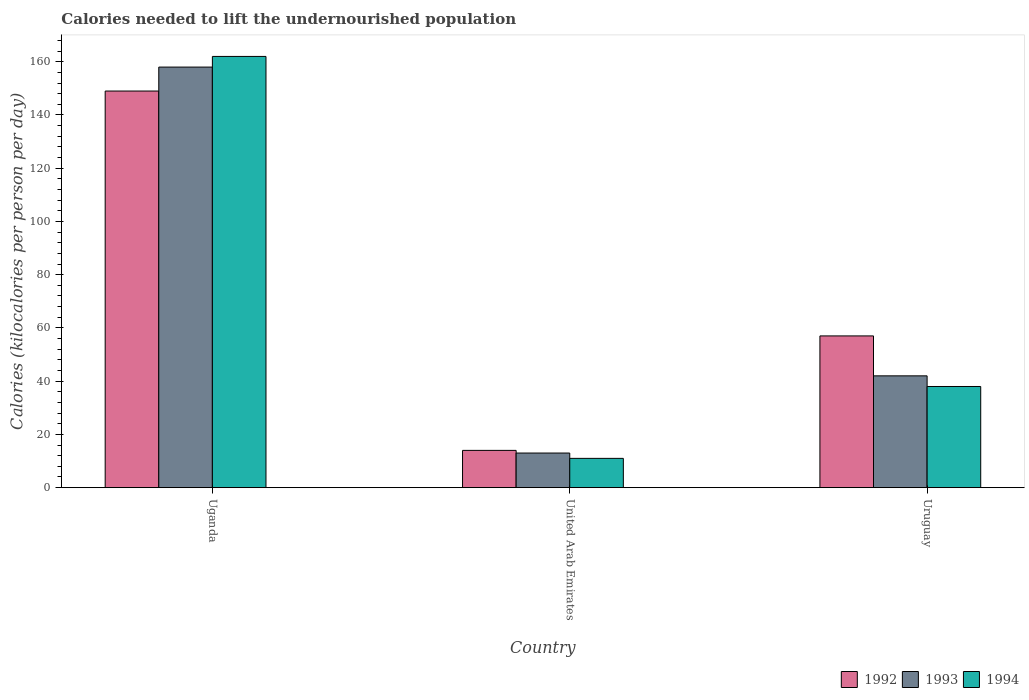How many different coloured bars are there?
Your response must be concise. 3. How many groups of bars are there?
Your answer should be compact. 3. Are the number of bars per tick equal to the number of legend labels?
Make the answer very short. Yes. Are the number of bars on each tick of the X-axis equal?
Make the answer very short. Yes. How many bars are there on the 3rd tick from the left?
Make the answer very short. 3. How many bars are there on the 3rd tick from the right?
Keep it short and to the point. 3. What is the label of the 2nd group of bars from the left?
Ensure brevity in your answer.  United Arab Emirates. What is the total calories needed to lift the undernourished population in 1994 in Uganda?
Your answer should be compact. 162. Across all countries, what is the maximum total calories needed to lift the undernourished population in 1994?
Your answer should be compact. 162. Across all countries, what is the minimum total calories needed to lift the undernourished population in 1994?
Your answer should be compact. 11. In which country was the total calories needed to lift the undernourished population in 1992 maximum?
Offer a very short reply. Uganda. In which country was the total calories needed to lift the undernourished population in 1994 minimum?
Offer a terse response. United Arab Emirates. What is the total total calories needed to lift the undernourished population in 1993 in the graph?
Give a very brief answer. 213. What is the difference between the total calories needed to lift the undernourished population in 1992 in Uganda and that in United Arab Emirates?
Ensure brevity in your answer.  135. What is the difference between the total calories needed to lift the undernourished population in 1993 in United Arab Emirates and the total calories needed to lift the undernourished population in 1994 in Uganda?
Offer a terse response. -149. What is the average total calories needed to lift the undernourished population in 1993 per country?
Your response must be concise. 71. What is the ratio of the total calories needed to lift the undernourished population in 1994 in Uganda to that in Uruguay?
Make the answer very short. 4.26. Is the total calories needed to lift the undernourished population in 1994 in Uganda less than that in United Arab Emirates?
Give a very brief answer. No. What is the difference between the highest and the second highest total calories needed to lift the undernourished population in 1992?
Your response must be concise. -92. What is the difference between the highest and the lowest total calories needed to lift the undernourished population in 1993?
Give a very brief answer. 145. In how many countries, is the total calories needed to lift the undernourished population in 1992 greater than the average total calories needed to lift the undernourished population in 1992 taken over all countries?
Give a very brief answer. 1. Is the sum of the total calories needed to lift the undernourished population in 1993 in Uganda and Uruguay greater than the maximum total calories needed to lift the undernourished population in 1992 across all countries?
Your response must be concise. Yes. What does the 1st bar from the right in United Arab Emirates represents?
Make the answer very short. 1994. How many bars are there?
Your answer should be compact. 9. How many countries are there in the graph?
Your answer should be very brief. 3. Are the values on the major ticks of Y-axis written in scientific E-notation?
Give a very brief answer. No. Does the graph contain any zero values?
Your answer should be compact. No. Does the graph contain grids?
Your response must be concise. No. Where does the legend appear in the graph?
Keep it short and to the point. Bottom right. How are the legend labels stacked?
Ensure brevity in your answer.  Horizontal. What is the title of the graph?
Your answer should be very brief. Calories needed to lift the undernourished population. What is the label or title of the Y-axis?
Offer a terse response. Calories (kilocalories per person per day). What is the Calories (kilocalories per person per day) of 1992 in Uganda?
Offer a terse response. 149. What is the Calories (kilocalories per person per day) of 1993 in Uganda?
Offer a very short reply. 158. What is the Calories (kilocalories per person per day) of 1994 in Uganda?
Your answer should be very brief. 162. What is the Calories (kilocalories per person per day) in 1992 in United Arab Emirates?
Your response must be concise. 14. What is the Calories (kilocalories per person per day) of 1994 in United Arab Emirates?
Your response must be concise. 11. What is the Calories (kilocalories per person per day) in 1992 in Uruguay?
Give a very brief answer. 57. Across all countries, what is the maximum Calories (kilocalories per person per day) in 1992?
Your answer should be very brief. 149. Across all countries, what is the maximum Calories (kilocalories per person per day) of 1993?
Your answer should be very brief. 158. Across all countries, what is the maximum Calories (kilocalories per person per day) in 1994?
Offer a terse response. 162. Across all countries, what is the minimum Calories (kilocalories per person per day) in 1992?
Provide a short and direct response. 14. What is the total Calories (kilocalories per person per day) of 1992 in the graph?
Make the answer very short. 220. What is the total Calories (kilocalories per person per day) of 1993 in the graph?
Keep it short and to the point. 213. What is the total Calories (kilocalories per person per day) of 1994 in the graph?
Your answer should be very brief. 211. What is the difference between the Calories (kilocalories per person per day) of 1992 in Uganda and that in United Arab Emirates?
Ensure brevity in your answer.  135. What is the difference between the Calories (kilocalories per person per day) of 1993 in Uganda and that in United Arab Emirates?
Offer a very short reply. 145. What is the difference between the Calories (kilocalories per person per day) in 1994 in Uganda and that in United Arab Emirates?
Keep it short and to the point. 151. What is the difference between the Calories (kilocalories per person per day) in 1992 in Uganda and that in Uruguay?
Your response must be concise. 92. What is the difference between the Calories (kilocalories per person per day) of 1993 in Uganda and that in Uruguay?
Ensure brevity in your answer.  116. What is the difference between the Calories (kilocalories per person per day) in 1994 in Uganda and that in Uruguay?
Give a very brief answer. 124. What is the difference between the Calories (kilocalories per person per day) of 1992 in United Arab Emirates and that in Uruguay?
Provide a short and direct response. -43. What is the difference between the Calories (kilocalories per person per day) of 1992 in Uganda and the Calories (kilocalories per person per day) of 1993 in United Arab Emirates?
Your answer should be very brief. 136. What is the difference between the Calories (kilocalories per person per day) of 1992 in Uganda and the Calories (kilocalories per person per day) of 1994 in United Arab Emirates?
Keep it short and to the point. 138. What is the difference between the Calories (kilocalories per person per day) in 1993 in Uganda and the Calories (kilocalories per person per day) in 1994 in United Arab Emirates?
Keep it short and to the point. 147. What is the difference between the Calories (kilocalories per person per day) in 1992 in Uganda and the Calories (kilocalories per person per day) in 1993 in Uruguay?
Offer a terse response. 107. What is the difference between the Calories (kilocalories per person per day) in 1992 in Uganda and the Calories (kilocalories per person per day) in 1994 in Uruguay?
Ensure brevity in your answer.  111. What is the difference between the Calories (kilocalories per person per day) of 1993 in Uganda and the Calories (kilocalories per person per day) of 1994 in Uruguay?
Provide a succinct answer. 120. What is the difference between the Calories (kilocalories per person per day) of 1992 in United Arab Emirates and the Calories (kilocalories per person per day) of 1993 in Uruguay?
Offer a very short reply. -28. What is the difference between the Calories (kilocalories per person per day) in 1992 in United Arab Emirates and the Calories (kilocalories per person per day) in 1994 in Uruguay?
Your response must be concise. -24. What is the average Calories (kilocalories per person per day) of 1992 per country?
Your answer should be very brief. 73.33. What is the average Calories (kilocalories per person per day) of 1994 per country?
Your answer should be compact. 70.33. What is the difference between the Calories (kilocalories per person per day) in 1993 and Calories (kilocalories per person per day) in 1994 in Uganda?
Keep it short and to the point. -4. What is the difference between the Calories (kilocalories per person per day) in 1992 and Calories (kilocalories per person per day) in 1993 in United Arab Emirates?
Provide a short and direct response. 1. What is the difference between the Calories (kilocalories per person per day) of 1992 and Calories (kilocalories per person per day) of 1993 in Uruguay?
Make the answer very short. 15. What is the ratio of the Calories (kilocalories per person per day) in 1992 in Uganda to that in United Arab Emirates?
Give a very brief answer. 10.64. What is the ratio of the Calories (kilocalories per person per day) in 1993 in Uganda to that in United Arab Emirates?
Provide a short and direct response. 12.15. What is the ratio of the Calories (kilocalories per person per day) of 1994 in Uganda to that in United Arab Emirates?
Provide a succinct answer. 14.73. What is the ratio of the Calories (kilocalories per person per day) of 1992 in Uganda to that in Uruguay?
Give a very brief answer. 2.61. What is the ratio of the Calories (kilocalories per person per day) in 1993 in Uganda to that in Uruguay?
Offer a very short reply. 3.76. What is the ratio of the Calories (kilocalories per person per day) of 1994 in Uganda to that in Uruguay?
Provide a succinct answer. 4.26. What is the ratio of the Calories (kilocalories per person per day) in 1992 in United Arab Emirates to that in Uruguay?
Offer a very short reply. 0.25. What is the ratio of the Calories (kilocalories per person per day) in 1993 in United Arab Emirates to that in Uruguay?
Offer a terse response. 0.31. What is the ratio of the Calories (kilocalories per person per day) of 1994 in United Arab Emirates to that in Uruguay?
Offer a terse response. 0.29. What is the difference between the highest and the second highest Calories (kilocalories per person per day) of 1992?
Your answer should be compact. 92. What is the difference between the highest and the second highest Calories (kilocalories per person per day) in 1993?
Your answer should be very brief. 116. What is the difference between the highest and the second highest Calories (kilocalories per person per day) of 1994?
Your answer should be very brief. 124. What is the difference between the highest and the lowest Calories (kilocalories per person per day) of 1992?
Provide a short and direct response. 135. What is the difference between the highest and the lowest Calories (kilocalories per person per day) of 1993?
Make the answer very short. 145. What is the difference between the highest and the lowest Calories (kilocalories per person per day) in 1994?
Give a very brief answer. 151. 